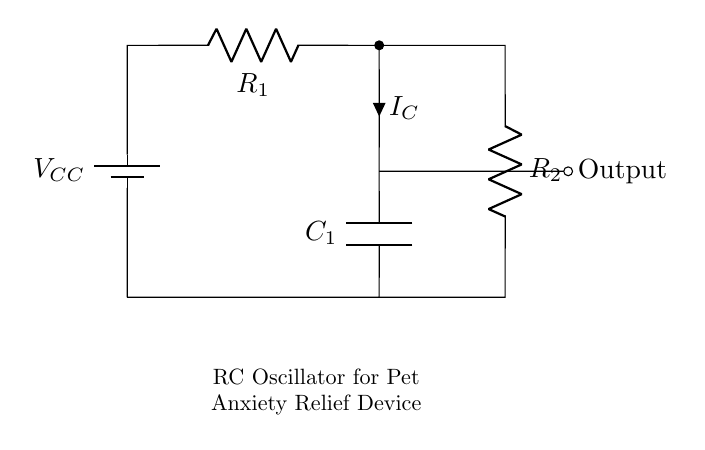What is the power supply voltage in this circuit? The circuit shows a label for a battery marked as V_CC. The diagram indicates that it is the source of voltage for the entire circuit.
Answer: V_CC What components are present in the circuit? The circuit contains a battery, two resistors, and a capacitor labeled R1, R2, and C1 respectively.
Answer: Battery, R1, R2, C1 What is the function of the capacitor in this oscillator circuit? Capacitors in an RC oscillator circuit play the role of storing energy and creating a time delay based on the RC time constant, which influences the oscillation frequency.
Answer: Energy storage and time delay What is the relationship between R1, R2, and the overall frequency of oscillation? The frequency of an RC oscillator depends on the resistor and capacitor values. The lower their values, the higher the frequency of oscillation. The output frequency is essentially influenced by the values of R1 and R2 as they affect the charge/discharge cycles of C1.
Answer: Lower values yield higher frequencies What is the output condition when the capacitor is fully charged? When the capacitor is fully charged, the current through the circuit stops momentarily until the capacitor discharges, causing the oscillation to resume. This state pertains to the operation of the circuit, wherein the output will indicate high impedance at that instant.
Answer: High impedance 